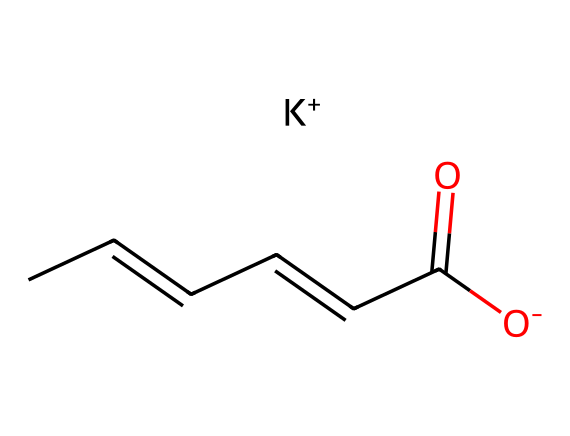What is the molecular formula of potassium sorbate? To determine the molecular formula, we can identify the elements and their counts in the SMILES representation. The structure contains carbon (C), hydrogen (H), oxygen (O), and potassium (K). Counting the atoms: there are 6 carbons, 8 hydrogens, 2 oxygens, and 1 potassium atom. Thus, the molecular formula is C6H7KO2.
Answer: C6H7KO2 How many carbon atoms are in potassium sorbate? By examining the SMILES structure, we can count the number of carbon atoms (C). The “CC=CC=CC” segment indicates 6 carbon atoms in total.
Answer: 6 What type of bond is present between the carbon atoms? The structure shows several carbon atoms connected by single and double bonds. The segment “C=C” indicates a double bond between the first two carbons, while the rest are connected by single bonds. Hence, both types of bonds are present.
Answer: single and double bonds What functional groups are present in potassium sorbate? In the SMILES notation, we can identify functional groups. The “C(=O)[O-]” indicates a carboxylate group (-COO-) which is common in preservatives; specifically, it shows the presence of a carboxyl group (–COOH), with a deprotonated oxygen (–O-).
Answer: carboxylate group What is the role of potassium in potassium sorbate? Potassium acts as a counterion to balance the charge of the carboxylate group (-O-) in the compound, providing stability to the molecule. The presence of the potassium ion also influences its solubility and activity as a preservative.
Answer: counterion Why is potassium sorbate effective as a preservative? Potassium sorbate works by inhibiting the growth of mold, yeast, and some bacteria. The structure, particularly the presence of the carboxylate group, allows it to interfere with the metabolism of microorganisms, effectively preventing spoilage.
Answer: inhibits microbial growth How is potassium sorbate classified in food chemistry? In food chemistry, potassium sorbate is classified as a preservative due to its ability to extend the shelf life of products by preventing spoilage from microbial growth, making it a widely used additive in various food items.
Answer: preservative 